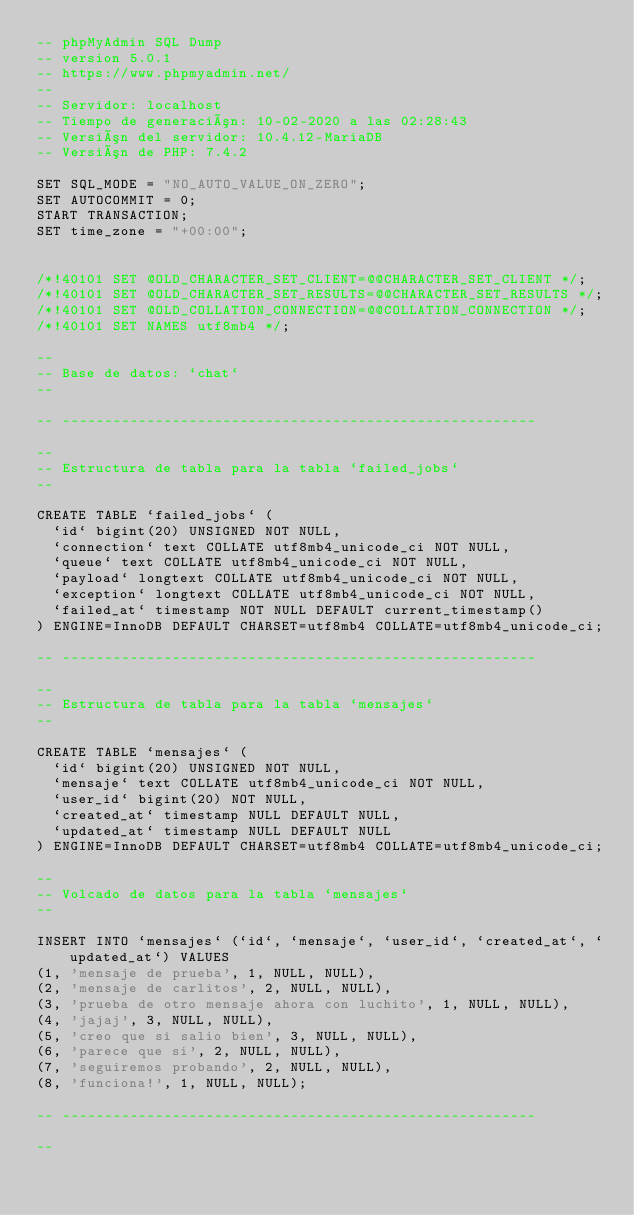Convert code to text. <code><loc_0><loc_0><loc_500><loc_500><_SQL_>-- phpMyAdmin SQL Dump
-- version 5.0.1
-- https://www.phpmyadmin.net/
--
-- Servidor: localhost
-- Tiempo de generación: 10-02-2020 a las 02:28:43
-- Versión del servidor: 10.4.12-MariaDB
-- Versión de PHP: 7.4.2

SET SQL_MODE = "NO_AUTO_VALUE_ON_ZERO";
SET AUTOCOMMIT = 0;
START TRANSACTION;
SET time_zone = "+00:00";


/*!40101 SET @OLD_CHARACTER_SET_CLIENT=@@CHARACTER_SET_CLIENT */;
/*!40101 SET @OLD_CHARACTER_SET_RESULTS=@@CHARACTER_SET_RESULTS */;
/*!40101 SET @OLD_COLLATION_CONNECTION=@@COLLATION_CONNECTION */;
/*!40101 SET NAMES utf8mb4 */;

--
-- Base de datos: `chat`
--

-- --------------------------------------------------------

--
-- Estructura de tabla para la tabla `failed_jobs`
--

CREATE TABLE `failed_jobs` (
  `id` bigint(20) UNSIGNED NOT NULL,
  `connection` text COLLATE utf8mb4_unicode_ci NOT NULL,
  `queue` text COLLATE utf8mb4_unicode_ci NOT NULL,
  `payload` longtext COLLATE utf8mb4_unicode_ci NOT NULL,
  `exception` longtext COLLATE utf8mb4_unicode_ci NOT NULL,
  `failed_at` timestamp NOT NULL DEFAULT current_timestamp()
) ENGINE=InnoDB DEFAULT CHARSET=utf8mb4 COLLATE=utf8mb4_unicode_ci;

-- --------------------------------------------------------

--
-- Estructura de tabla para la tabla `mensajes`
--

CREATE TABLE `mensajes` (
  `id` bigint(20) UNSIGNED NOT NULL,
  `mensaje` text COLLATE utf8mb4_unicode_ci NOT NULL,
  `user_id` bigint(20) NOT NULL,
  `created_at` timestamp NULL DEFAULT NULL,
  `updated_at` timestamp NULL DEFAULT NULL
) ENGINE=InnoDB DEFAULT CHARSET=utf8mb4 COLLATE=utf8mb4_unicode_ci;

--
-- Volcado de datos para la tabla `mensajes`
--

INSERT INTO `mensajes` (`id`, `mensaje`, `user_id`, `created_at`, `updated_at`) VALUES
(1, 'mensaje de prueba', 1, NULL, NULL),
(2, 'mensaje de carlitos', 2, NULL, NULL),
(3, 'prueba de otro mensaje ahora con luchito', 1, NULL, NULL),
(4, 'jajaj', 3, NULL, NULL),
(5, 'creo que si salio bien', 3, NULL, NULL),
(6, 'parece que si', 2, NULL, NULL),
(7, 'seguiremos probando', 2, NULL, NULL),
(8, 'funciona!', 1, NULL, NULL);

-- --------------------------------------------------------

--</code> 